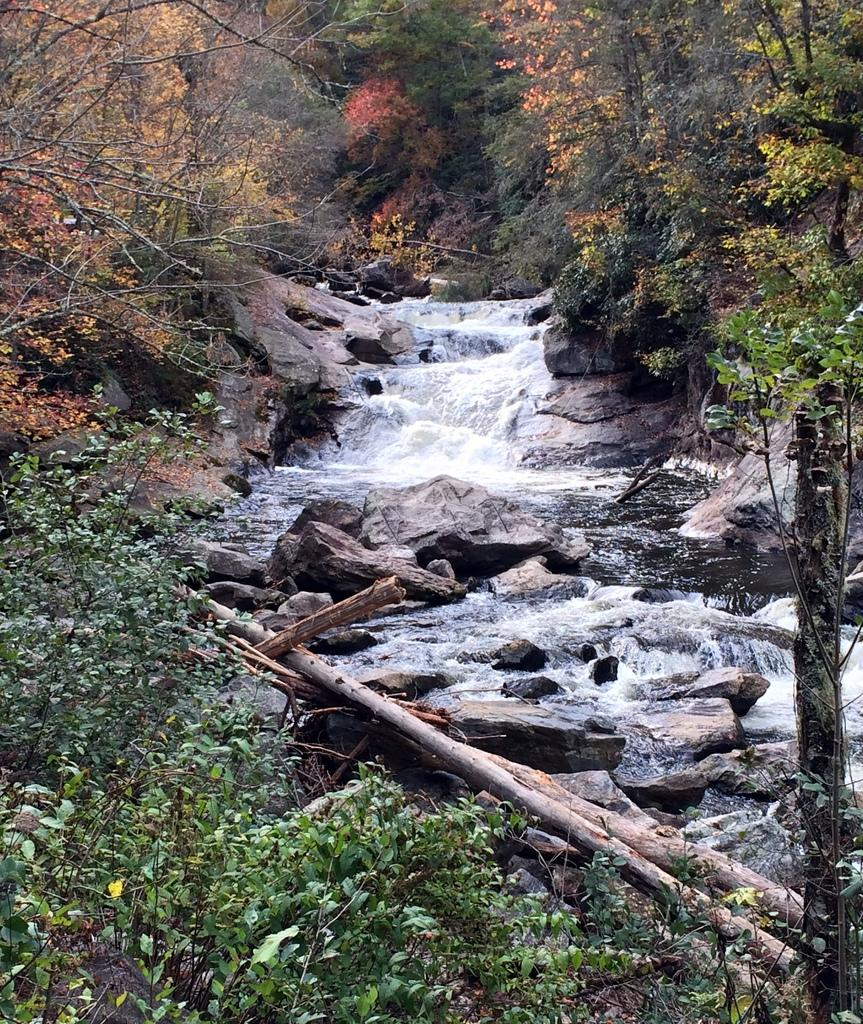What natural feature is the main subject of the image? There is a waterfall in the image. What type of vegetation can be seen in the image? There are trees and plants in the image. What structures are present in the image? There are wooden poles in the image. What is the waterfall flowing over in the image? There are rocks in the water in the image. What type of jelly can be seen on the stove in the image? There is no jelly or stove present in the image; it features a waterfall, trees, plants, wooden poles, and rocks in the water. 